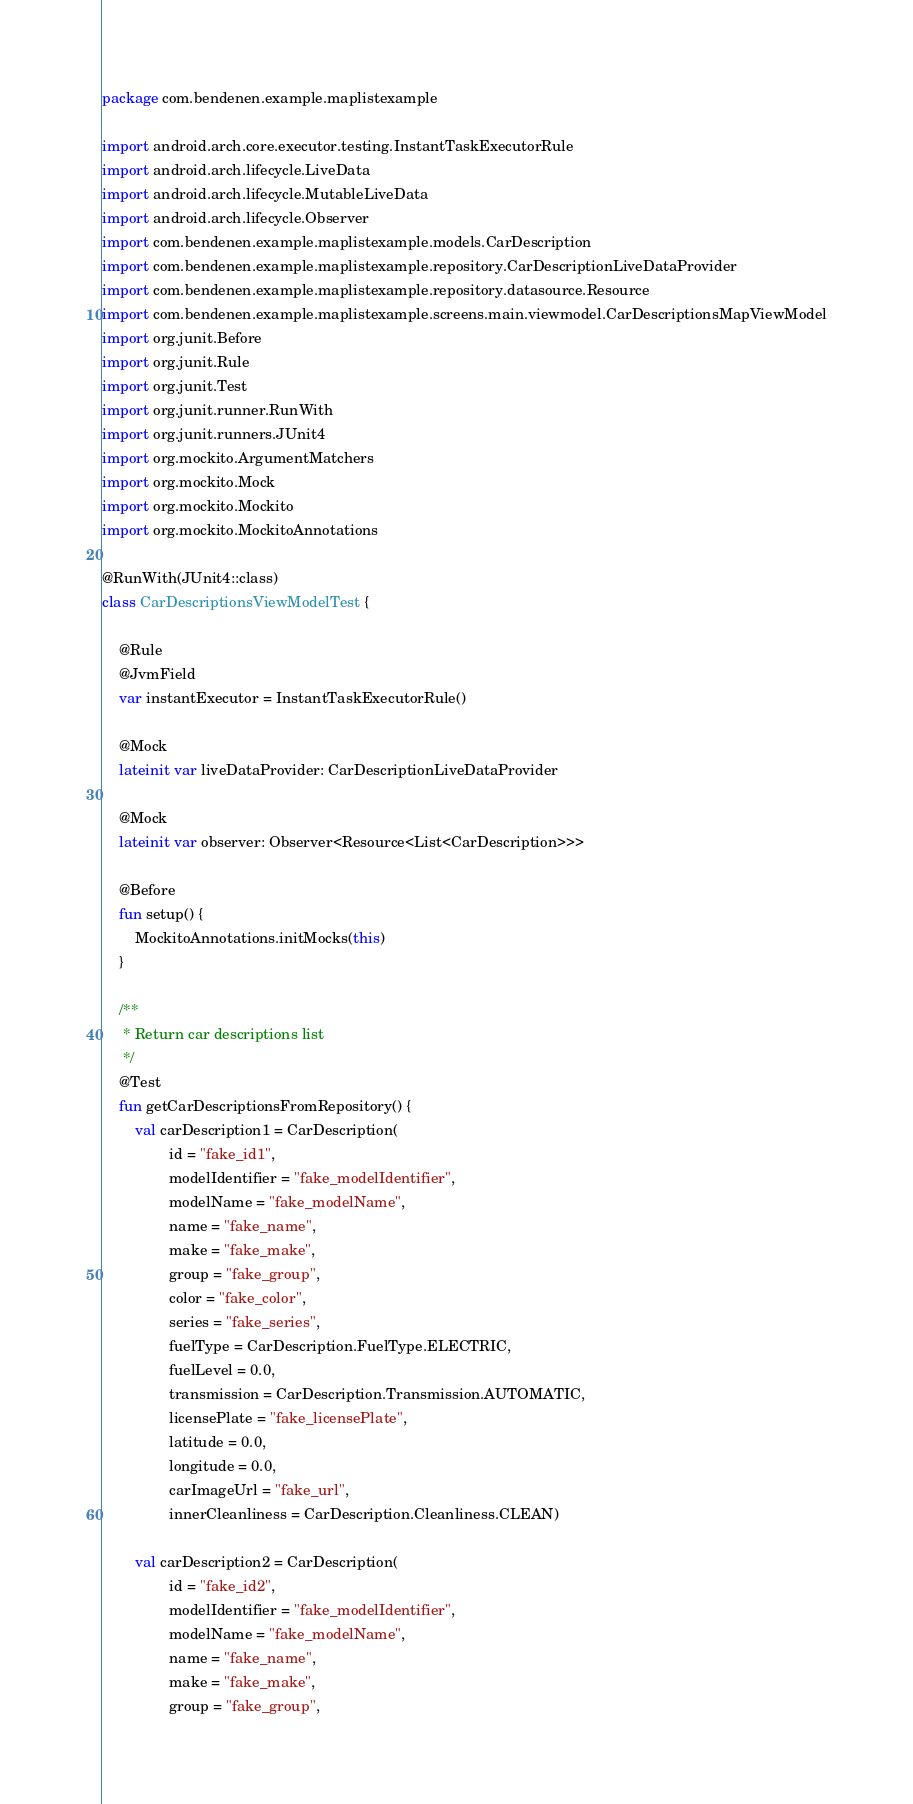<code> <loc_0><loc_0><loc_500><loc_500><_Kotlin_>package com.bendenen.example.maplistexample

import android.arch.core.executor.testing.InstantTaskExecutorRule
import android.arch.lifecycle.LiveData
import android.arch.lifecycle.MutableLiveData
import android.arch.lifecycle.Observer
import com.bendenen.example.maplistexample.models.CarDescription
import com.bendenen.example.maplistexample.repository.CarDescriptionLiveDataProvider
import com.bendenen.example.maplistexample.repository.datasource.Resource
import com.bendenen.example.maplistexample.screens.main.viewmodel.CarDescriptionsMapViewModel
import org.junit.Before
import org.junit.Rule
import org.junit.Test
import org.junit.runner.RunWith
import org.junit.runners.JUnit4
import org.mockito.ArgumentMatchers
import org.mockito.Mock
import org.mockito.Mockito
import org.mockito.MockitoAnnotations

@RunWith(JUnit4::class)
class CarDescriptionsViewModelTest {

    @Rule
    @JvmField
    var instantExecutor = InstantTaskExecutorRule()

    @Mock
    lateinit var liveDataProvider: CarDescriptionLiveDataProvider

    @Mock
    lateinit var observer: Observer<Resource<List<CarDescription>>>

    @Before
    fun setup() {
        MockitoAnnotations.initMocks(this)
    }

    /**
     * Return car descriptions list
     */
    @Test
    fun getCarDescriptionsFromRepository() {
        val carDescription1 = CarDescription(
                id = "fake_id1",
                modelIdentifier = "fake_modelIdentifier",
                modelName = "fake_modelName",
                name = "fake_name",
                make = "fake_make",
                group = "fake_group",
                color = "fake_color",
                series = "fake_series",
                fuelType = CarDescription.FuelType.ELECTRIC,
                fuelLevel = 0.0,
                transmission = CarDescription.Transmission.AUTOMATIC,
                licensePlate = "fake_licensePlate",
                latitude = 0.0,
                longitude = 0.0,
                carImageUrl = "fake_url",
                innerCleanliness = CarDescription.Cleanliness.CLEAN)

        val carDescription2 = CarDescription(
                id = "fake_id2",
                modelIdentifier = "fake_modelIdentifier",
                modelName = "fake_modelName",
                name = "fake_name",
                make = "fake_make",
                group = "fake_group",</code> 